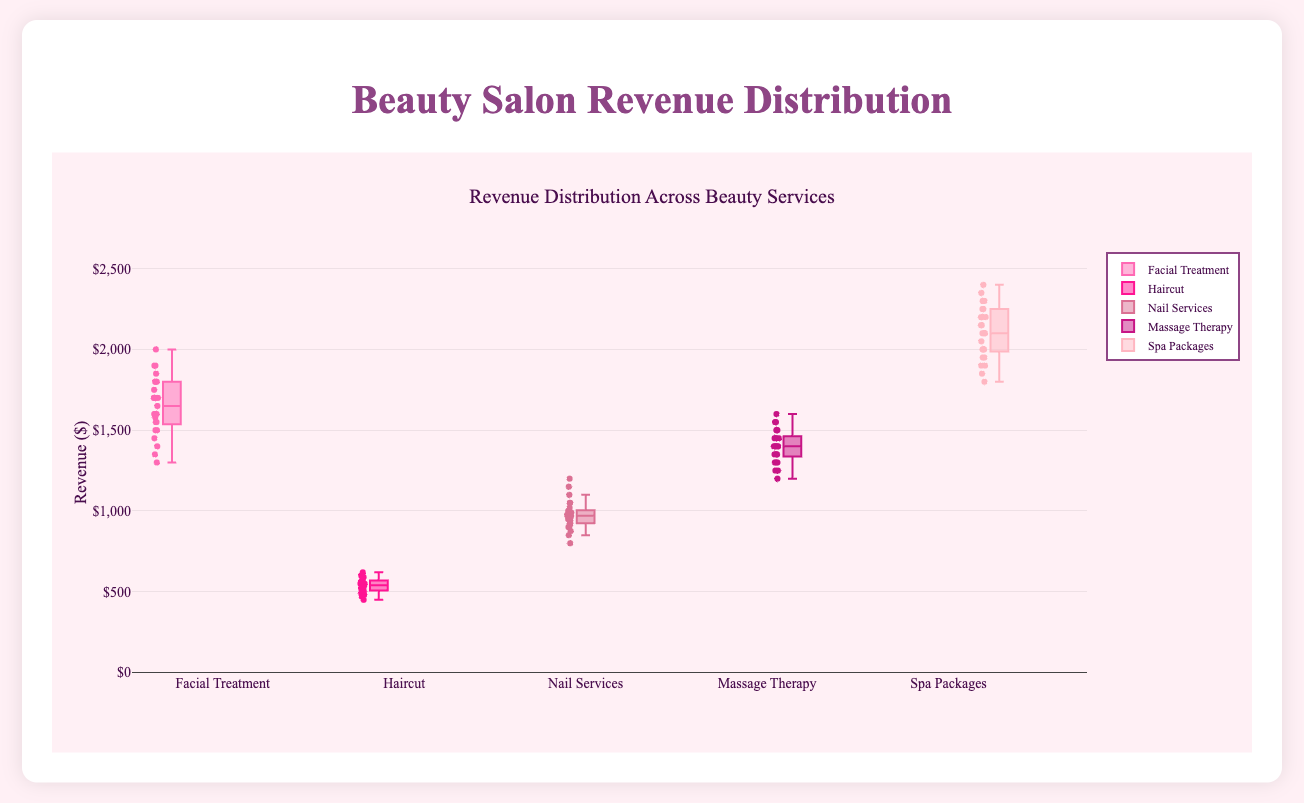What's the title of the figure? The title is displayed at the top of the figure and usually highlights the main subject of the visualization.
Answer: Beauty Salon Revenue Distribution What is the range of revenues shown on the y-axis? Observing the y-axis, the range is indicated by the lowest and highest values on the axis.
Answer: 0 to 2600 Which service has the highest median revenue? By looking at the central line within each box plot, which represents the median, we can compare them across services.
Answer: Spa Packages How does the revenue distribution for Haircut compare to Nail Services in Salon A? To compare, look at the whiskers, box, and any outliers in the box plots of Haircut and Nail Services for Salon A. Nail Services shows a generally higher revenue distribution with a higher median than Haircut.
Answer: Nail Services has higher revenue What is the interquartile range (IQR) for Facial Treatment? The IQR is calculated by subtracting the value at the lower quartile (bottom of the box) from the value at the upper quartile (top of the box). For Facial Treatment, subtract the bottom value of the box from the top value.
Answer: About 200 Which service displays the most consistent revenue distribution across all Salons? Consistency is indicated by smaller boxes and shorter whiskers. Evaluate all boxes and whiskers to see which is the smallest.
Answer: Haircut Compare the revenue spread for Spa Packages and Massage Therapy. Which has a wider spread? The spread is indicated by the length of the whiskers and the size of the box. Compare the width of both Spa Packages and Massage Therapy box plots.
Answer: Spa Packages Which service shows the minimum revenue and which salon is it from? The minimum revenue is represented by the lowest data point in the box plots. Find the lowest point across all services and note the corresponding salon.
Answer: Haircut from Salon B How do the median revenues of Facial Treatment in Salon A and Salon D compare? By observing the central lines within the boxes for Facial Treatment in Salon A and Salon D, compare their positioning on the y-axis.
Answer: Salon A has a higher median What is the maximum recorded revenue for any service, and which service does it belong to? The maximum revenue is indicated by the highest data point in the box plots. Identify this point and its corresponding service.
Answer: Spa Packages 